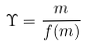<formula> <loc_0><loc_0><loc_500><loc_500>\Upsilon = \frac { m } { f ( m ) }</formula> 